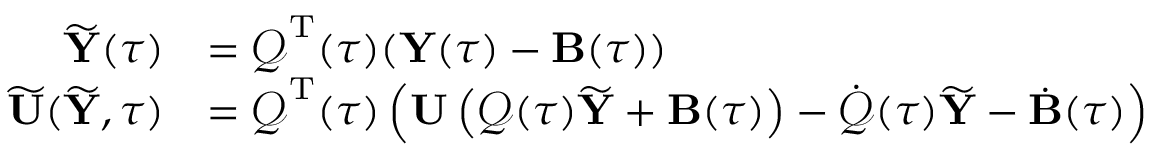Convert formula to latex. <formula><loc_0><loc_0><loc_500><loc_500>\begin{array} { r l } { \widetilde { \mathbf Y } ( \tau ) } & { = \mathcal { Q } ^ { \mathrm T } ( \tau ) ( { \mathbf Y } ( \tau ) - { \mathbf B } ( \tau ) ) } \\ { \widetilde { \mathbf U } ( \widetilde { \mathbf Y } , \tau ) } & { = \mathcal { Q } ^ { \mathrm T } ( \tau ) \left ( { \mathbf U } \left ( \mathcal { Q } ( \tau ) \widetilde { \mathbf Y } + { \mathbf B } ( \tau ) \right ) - \dot { \mathcal { Q } } ( \tau ) \widetilde { \mathbf Y } - \dot { \mathbf B } ( \tau ) \right ) } \end{array}</formula> 